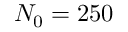<formula> <loc_0><loc_0><loc_500><loc_500>N _ { 0 } = 2 5 0</formula> 